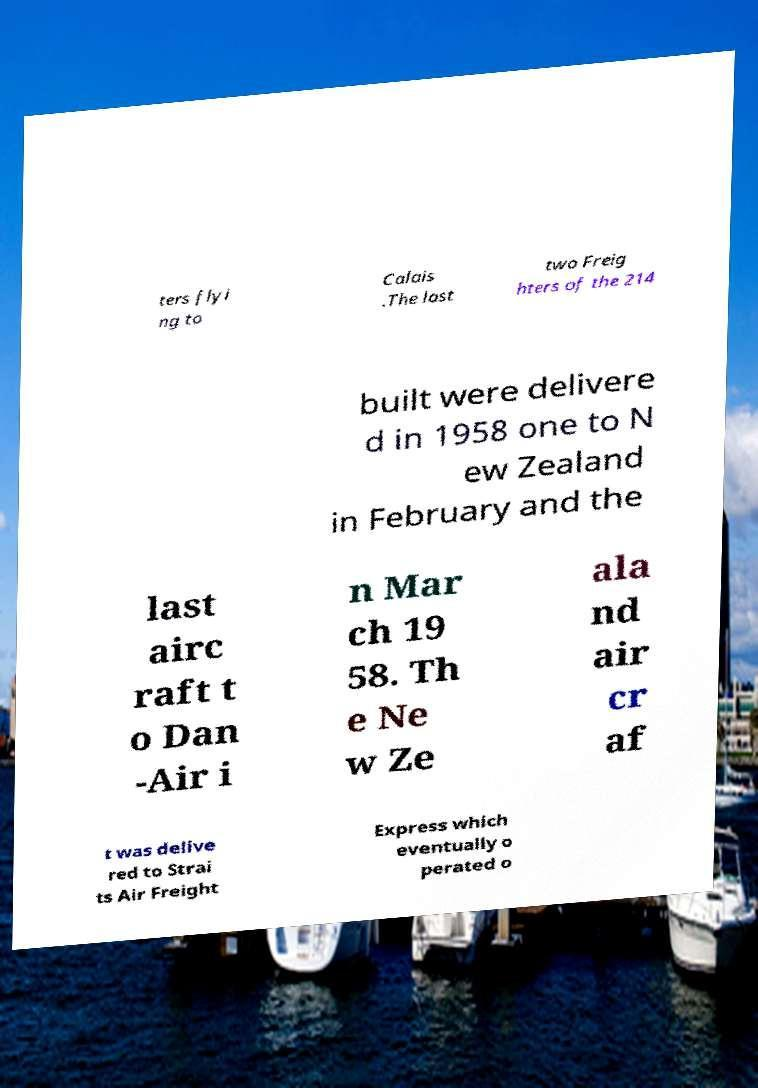For documentation purposes, I need the text within this image transcribed. Could you provide that? ters flyi ng to Calais .The last two Freig hters of the 214 built were delivere d in 1958 one to N ew Zealand in February and the last airc raft t o Dan -Air i n Mar ch 19 58. Th e Ne w Ze ala nd air cr af t was delive red to Strai ts Air Freight Express which eventually o perated o 